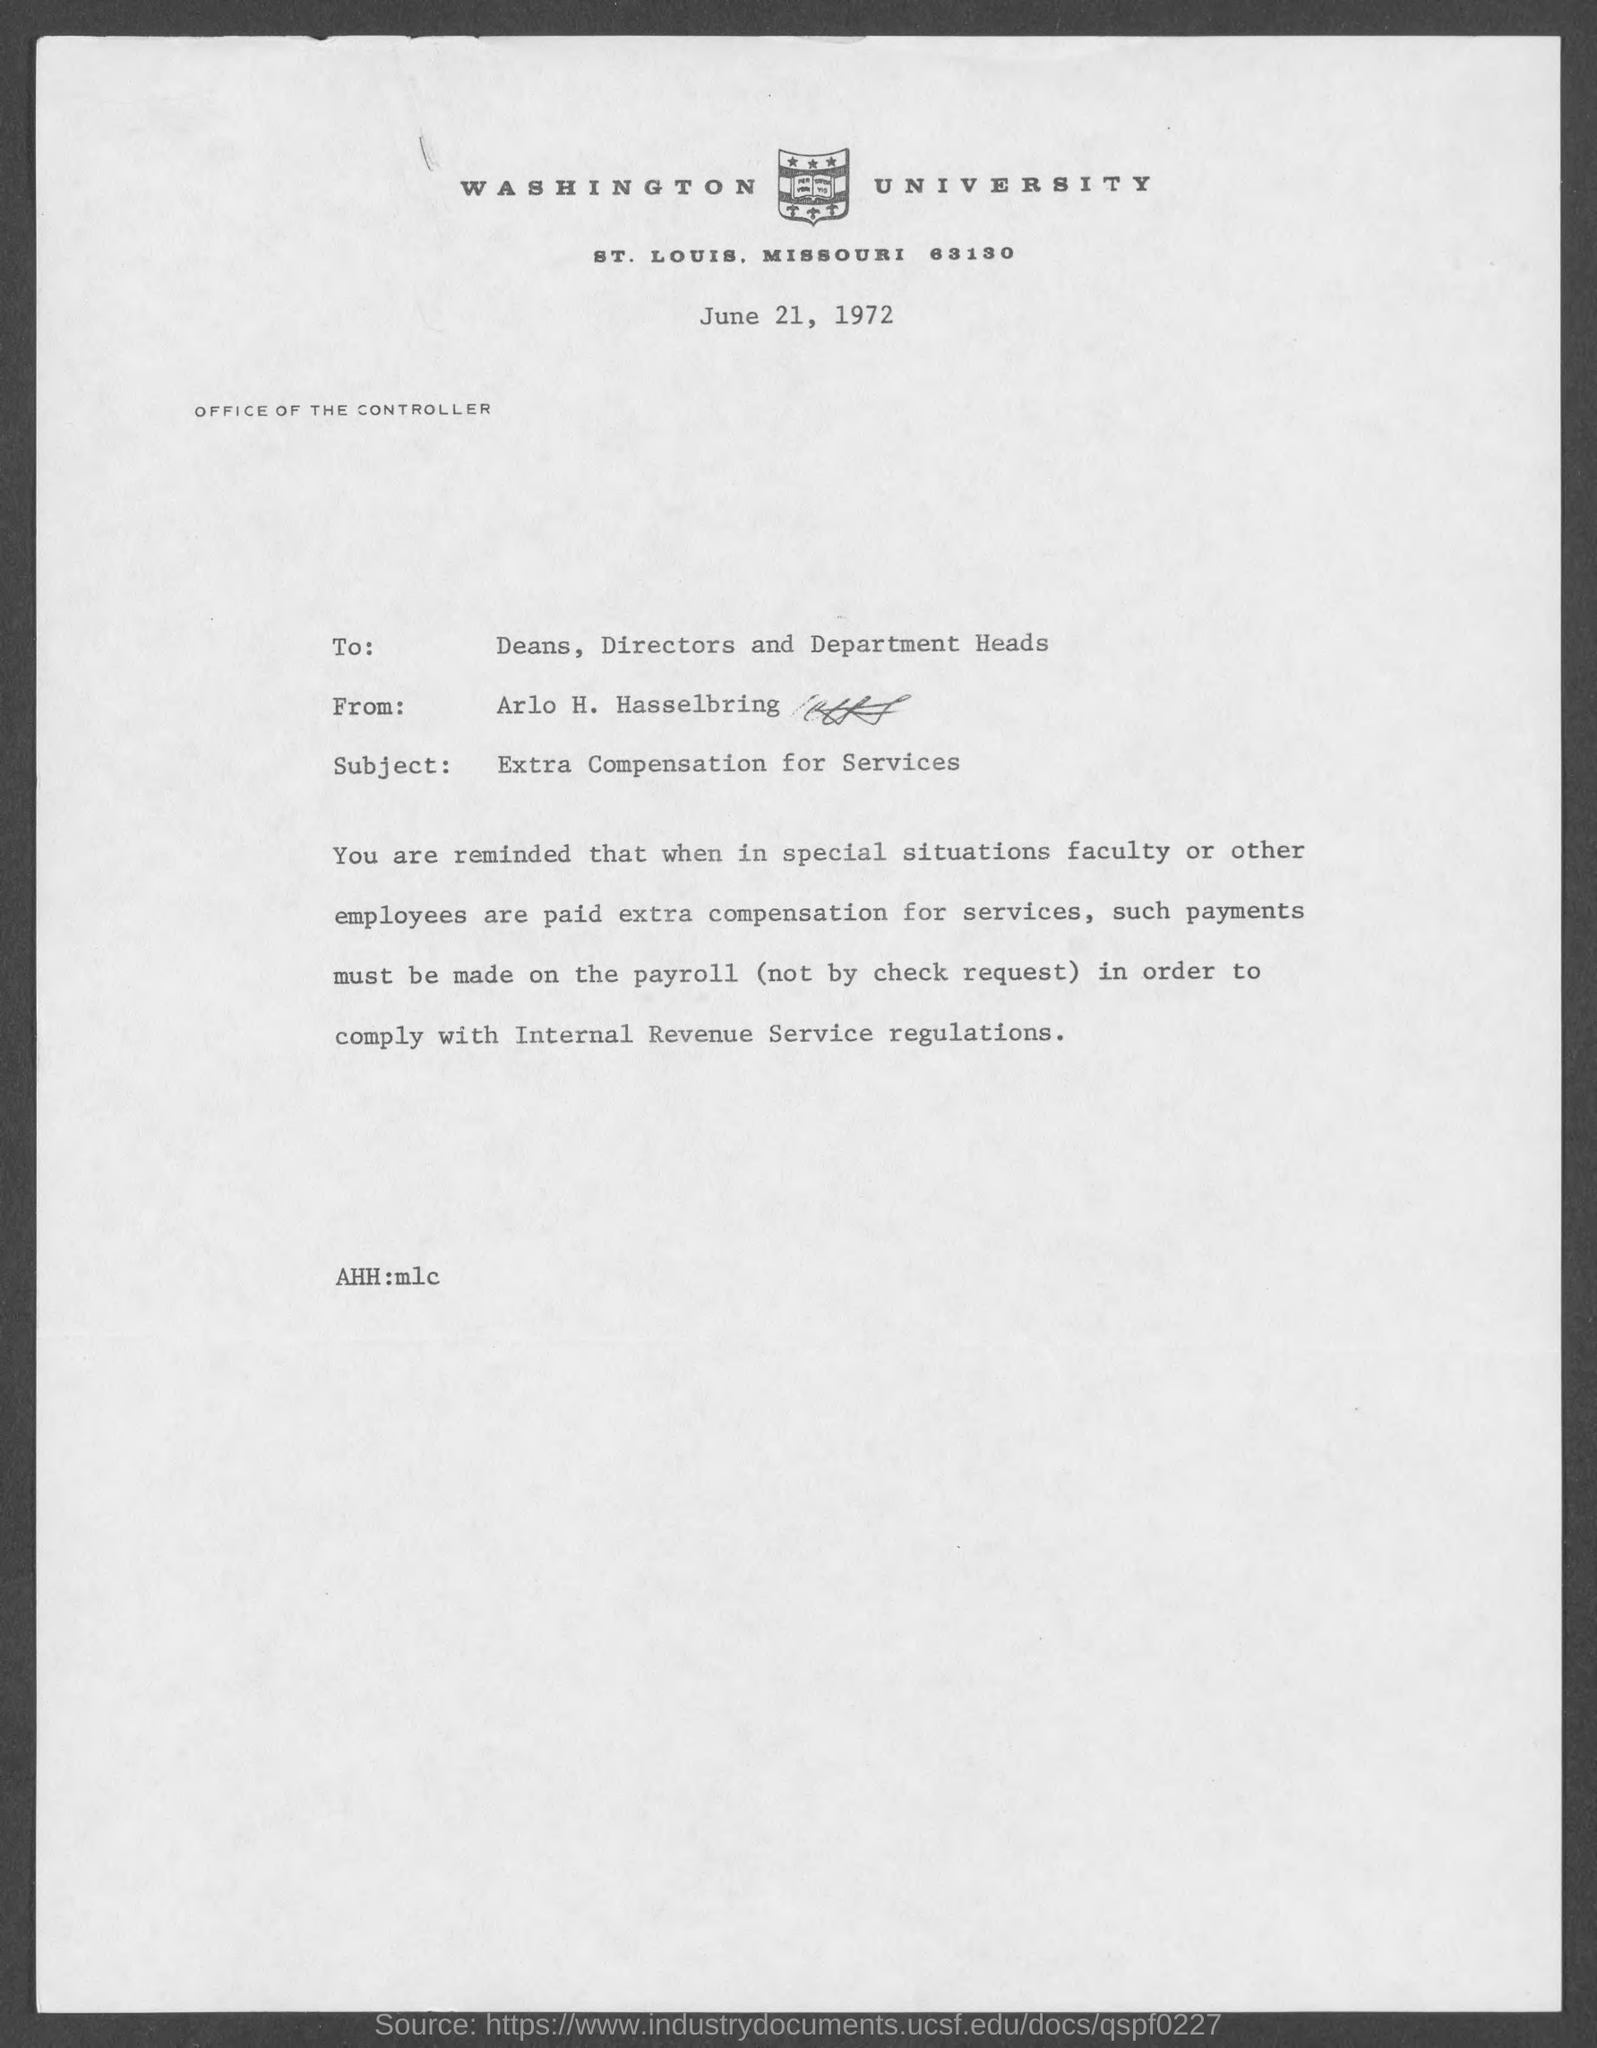Which University is mentioned in the letter head?
Make the answer very short. Washington University. Who is the sender of this memo?
Keep it short and to the point. Arlo H. Hasselbring. To whom, the memo is addressed?
Keep it short and to the point. Deans, Directors and Department Heads. What is the date mentioned in this memo?
Your response must be concise. June 21, 1972. 